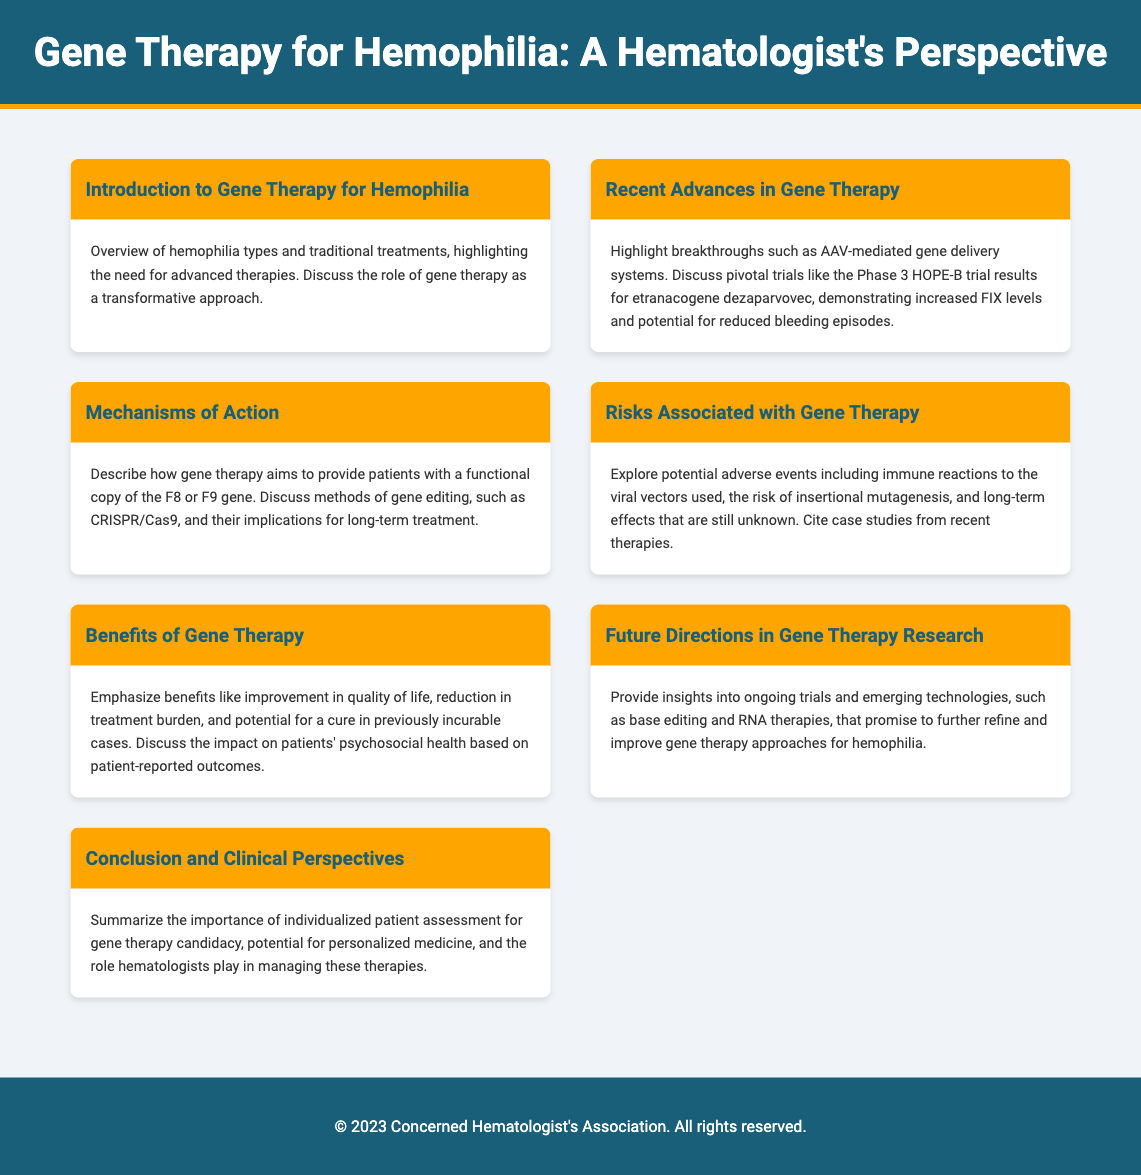What is gene therapy for hemophilia? Gene therapy for hemophilia is a transformative approach that seeks to provide a functional copy of the F8 or F9 gene.
Answer: Transformative approach What trial results were highlighted in the document? The document discusses the Phase 3 HOPE-B trial results for etranacogene dezaparvovec.
Answer: Phase 3 HOPE-B trial What mechanisms are discussed for gene editing? The document mentions CRISPR/Cas9 as a method of gene editing.
Answer: CRISPR/Cas9 What are the potential adverse events mentioned? Potential adverse events include immune reactions to viral vectors, risk of insertional mutagenesis, and unknown long-term effects.
Answer: Immune reactions, insertional mutagenesis What psychosocial benefits does gene therapy offer? The document emphasizes improvement in quality of life and reduction in treatment burden.
Answer: Quality of life improvement What future technologies are mentioned for gene therapy? The document mentions base editing and RNA therapies as emerging technologies.
Answer: Base editing and RNA therapies Who plays a role in managing gene therapy? Hematologists are mentioned as playing a role in managing these therapies.
Answer: Hematologists 